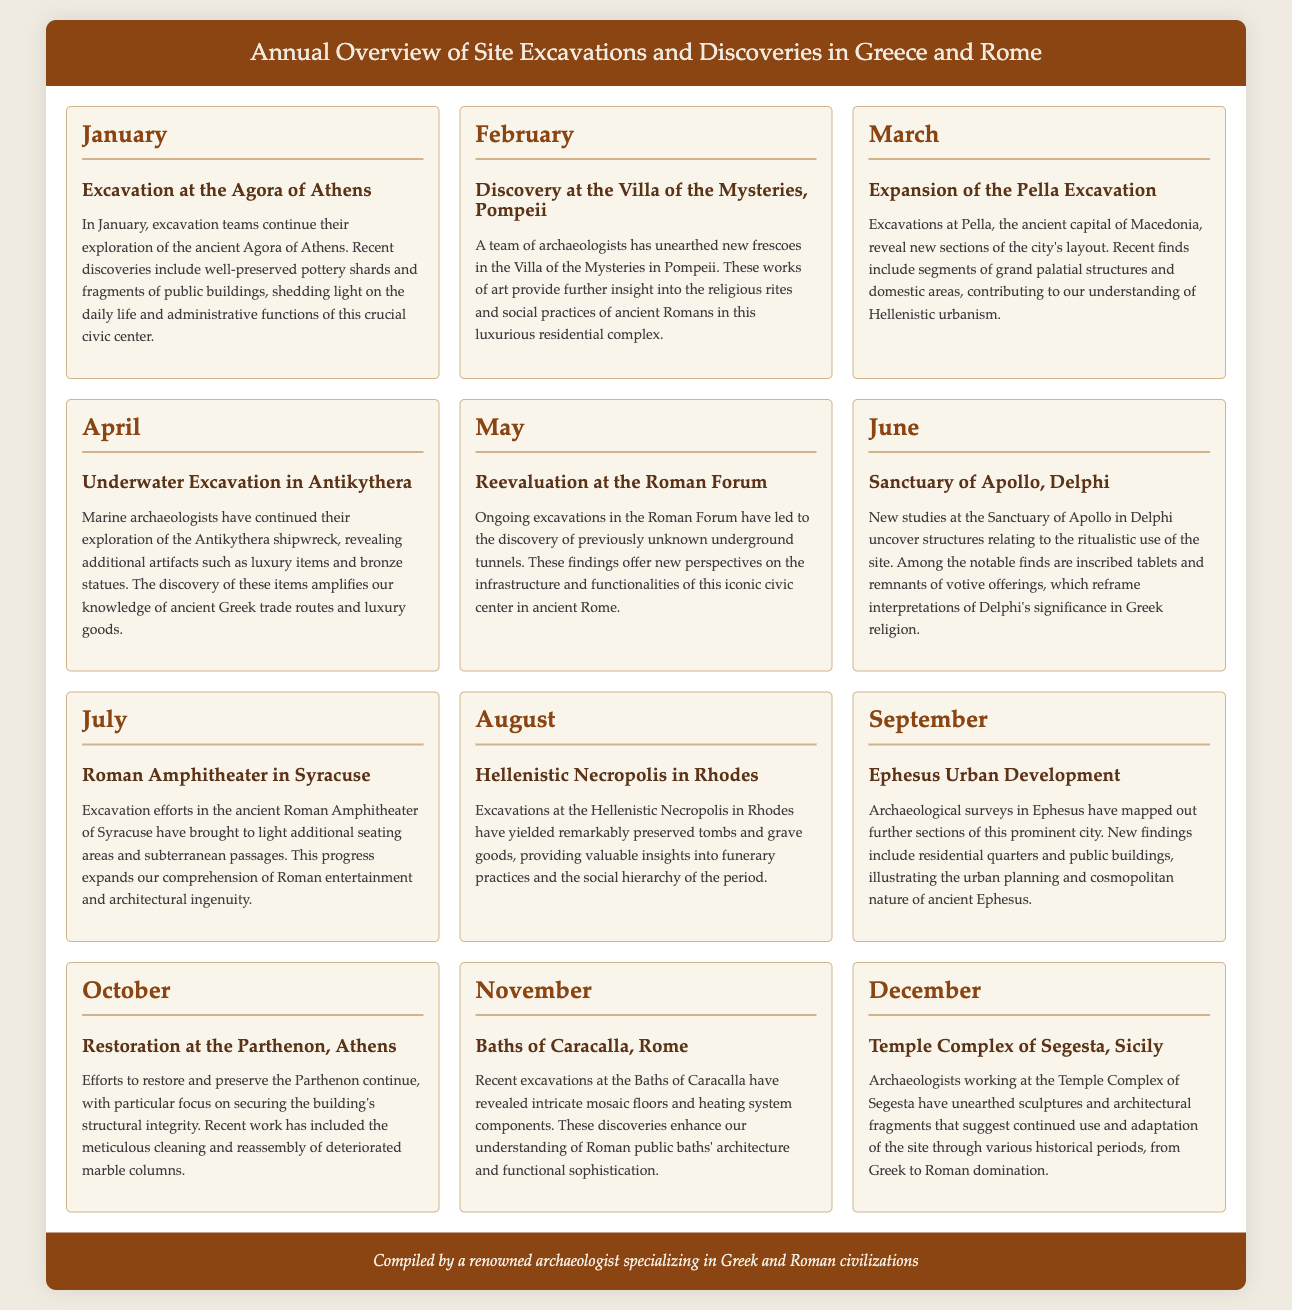What excavation occurred in January? The document lists the excavation at the Agora of Athens as the activity for January.
Answer: Agora of Athens What significant discovery was made in February? The document mentions that new frescoes were unearthed in the Villa of the Mysteries, Pompeii.
Answer: New frescoes Which site had ongoing excavations in May? The document states that ongoing excavations were conducted in the Roman Forum during May.
Answer: Roman Forum What was uncovered at the Sanctuary of Apollo in June? The document notes that inscribed tablets and remnants of votive offerings were uncovered at the Sanctuary of Apollo, Delphi.
Answer: Inscribed tablets and votive offerings How many months are covered in the document? The document presents information for twelve months of excavation and discoveries.
Answer: Twelve 